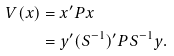Convert formula to latex. <formula><loc_0><loc_0><loc_500><loc_500>V ( x ) & = x ^ { \prime } P x \\ & = y ^ { \prime } ( S ^ { - 1 } ) ^ { \prime } P S ^ { - 1 } y .</formula> 